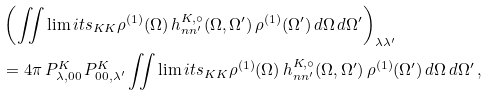<formula> <loc_0><loc_0><loc_500><loc_500>& \left ( \iint \lim i t s _ { K K } \rho ^ { ( 1 ) } ( \Omega ) \, h ^ { K , \circ } _ { n n ^ { \prime } } ( \Omega , \Omega ^ { \prime } ) \, \rho ^ { ( 1 ) } ( \Omega ^ { \prime } ) \, d \Omega \, d \Omega ^ { \prime } \right ) _ { \lambda \lambda ^ { \prime } } \\ & = 4 \pi \, P ^ { K } _ { \lambda , 0 0 } \, P ^ { K } _ { 0 0 , \lambda ^ { \prime } } \iint \lim i t s _ { K K } \rho ^ { ( 1 ) } ( \Omega ) \, h ^ { K , \circ } _ { n n ^ { \prime } } ( \Omega , \Omega ^ { \prime } ) \, \rho ^ { ( 1 ) } ( \Omega ^ { \prime } ) \, d \Omega \, d \Omega ^ { \prime } \, ,</formula> 